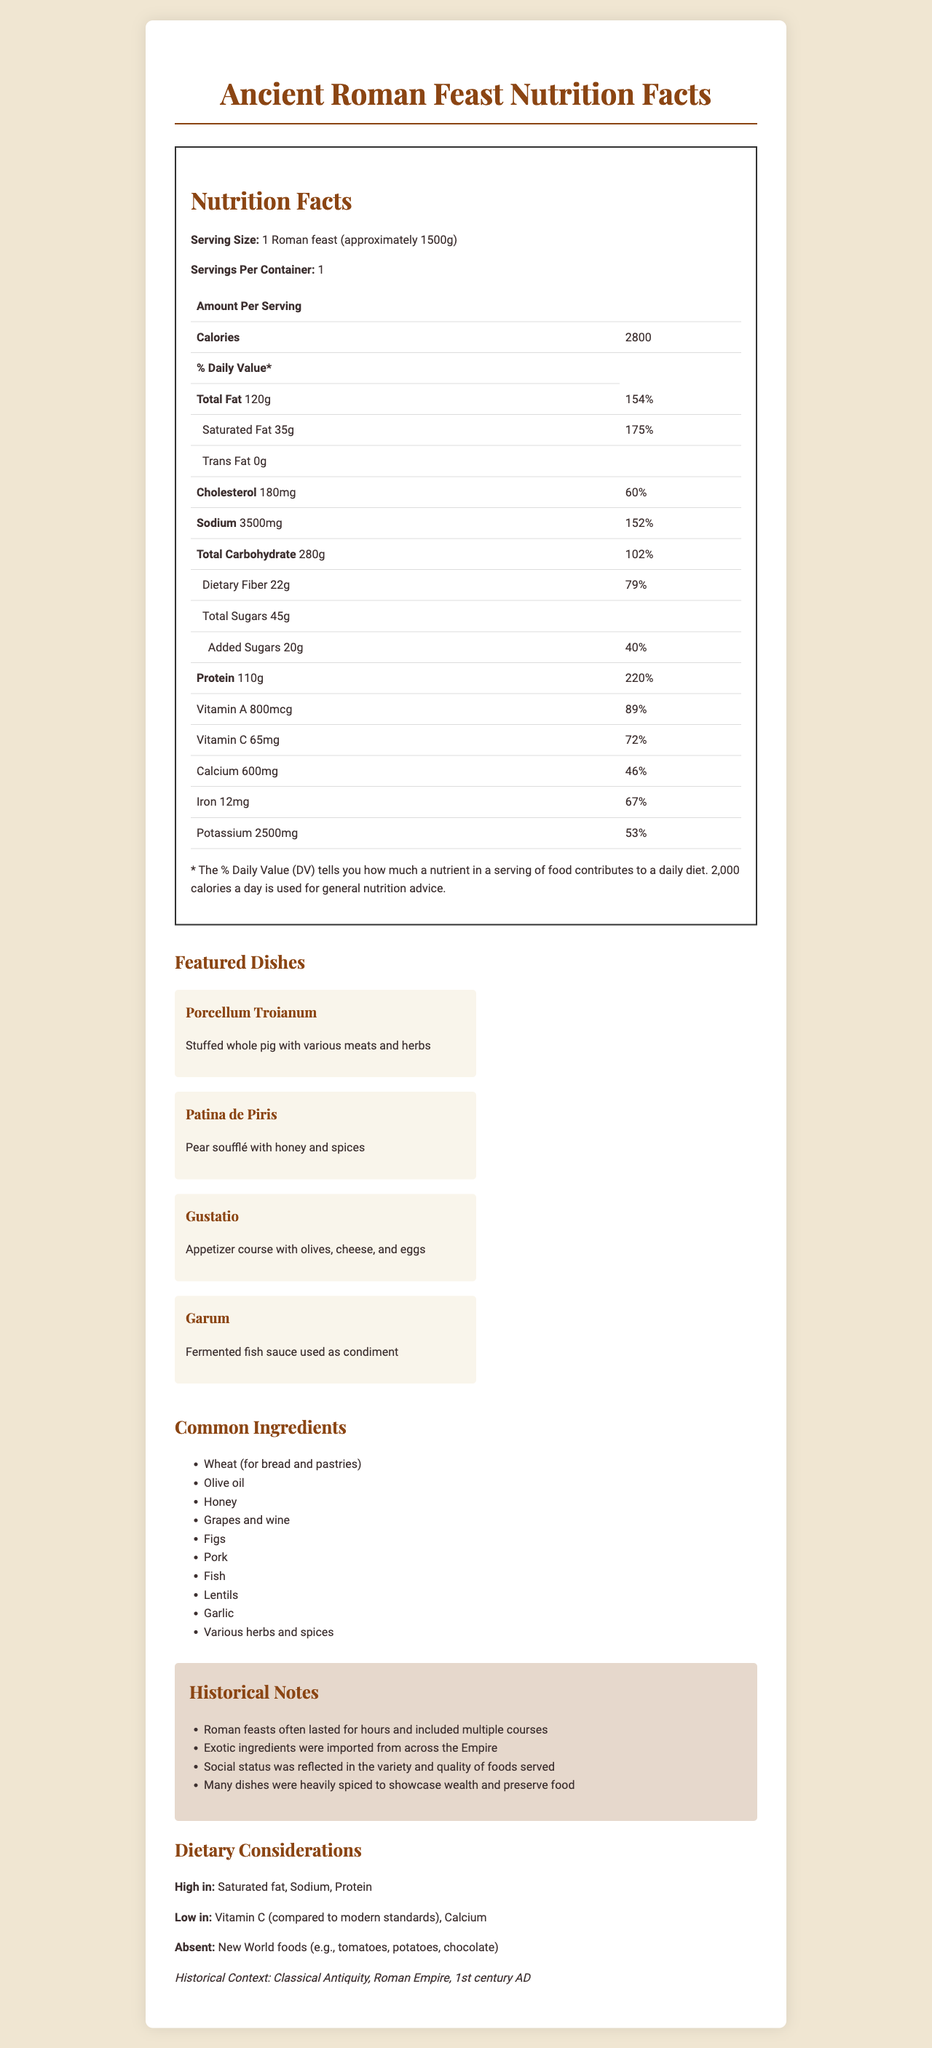what is the serving size of the Roman feast? The serving size is listed at the top of the Nutrition Facts label and is specified as "1 Roman feast (approximately 1500g)".
Answer: 1 Roman feast (approximately 1500g) How many calories does one Roman feast contain? The Nutrition Facts label indicates that one serving of the Roman feast contains 2800 calories.
Answer: 2800 What is the total fat content in a serving of the Roman feast? The total fat content is listed on the Nutrition Facts label as 120g per serving.
Answer: 120g What is the daily value percentage for sodium in one serving? The daily value percentage for sodium is listed on the Nutrition Facts label as 152%.
Answer: 152% How much protein does one Roman feast provide? The amount of protein in one serving is listed as 110g.
Answer: 110g Which of the following is not a featured dish in the Roman feast? A. Porcellum Troianum B. Patina de Piris C. Gustatio D. Hamburger Hamburger is not listed as a featured dish; the listed dishes are Porcellum Troianum, Patina de Piris, and Gustatio.
Answer: D How many grams of dietary fiber are in one serving of the Roman feast? The amount of dietary fiber is listed on the Nutrition Facts label as 22g per serving.
Answer: 22g Does the Roman feast contain any trans fat? The Nutrition Facts label indicates that there is 0g of trans fat in the Roman feast.
Answer: No What time period and region does the Roman feast belong to? A. 15th century Europe B. 1st century AD Roman Empire C. 18th century China D. 20th century USA The historical context mentioned in the document is the Classical Antiquity, Roman Empire, specifically the 1st century AD.
Answer: B Summarize the main idea of the document. The document features a Nutrition Facts label showcasing the nutritional content of a Roman feast, highlights various dishes served, lists common ingredients used, delves into the historical context, and outlines dietary considerations, reflecting the foods available in classical antiquity in the Roman Empire during the 1st century AD.
Answer: The document provides a detailed Nutrition Facts label for an ancient Roman feast, including nutritional information, descriptions of featured dishes, common ingredients, historical context, and dietary considerations. What exotic pairing was brought from the New World to the Roman Empire? The document specifically states that New World foods such as tomatoes and potatoes were absent from the Roman feast, so we cannot determine any exotic pairing brought from the New World.
Answer: Cannot be determined Which nutrient has the highest daily value percentage in the Roman feast? The daily value percentages are listed for each nutrient, and the highest listed is for protein at 220%.
Answer: Protein (220%) Does the Nutrition Facts label indicate any Vitamin D content? The document does not provide any information about Vitamin D content in the Roman feast.
Answer: No 